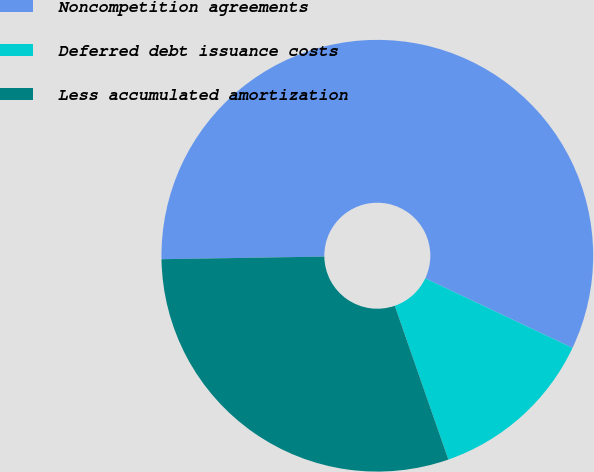Convert chart to OTSL. <chart><loc_0><loc_0><loc_500><loc_500><pie_chart><fcel>Noncompetition agreements<fcel>Deferred debt issuance costs<fcel>Less accumulated amortization<nl><fcel>57.28%<fcel>12.64%<fcel>30.08%<nl></chart> 